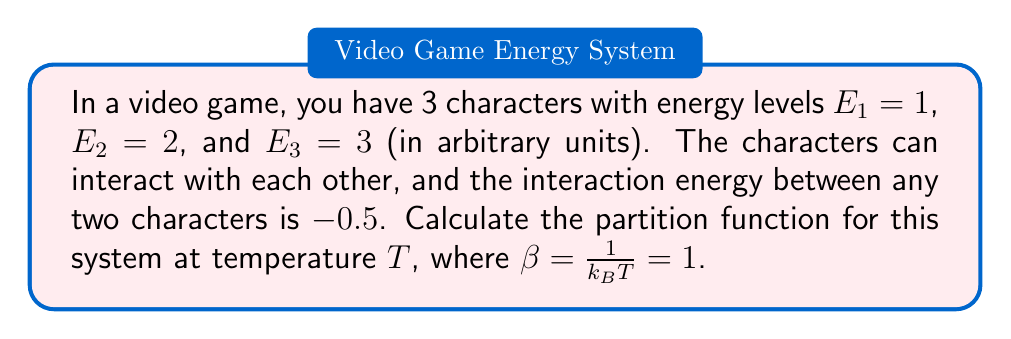Teach me how to tackle this problem. Let's approach this step-by-step:

1) The partition function Z is given by:

   $$Z = \sum_i e^{-\beta E_i}$$

   where $E_i$ is the energy of each microstate.

2) In this case, we need to consider all possible configurations of the characters:

   - All characters separate: $(1, 1, 1)$
   - Two characters interacting: $(2, 1)$, $(2, 1)$, $(2, 1)$
   - All characters interacting: $(3)$

3) Let's calculate the energy and Boltzmann factor for each configuration:

   - All separate: $E = 1 + 2 + 3 = 6$
     $$e^{-\beta E} = e^{-6} \approx 0.0025$$

   - Two interacting (3 possibilities):
     $E = (1 + 2 - 0.5) + 3 = 5.5$
     $$3 \cdot e^{-\beta E} = 3 \cdot e^{-5.5} \approx 0.0123$$

   - All interacting:
     $E = 1 + 2 + 3 - 0.5 - 0.5 - 0.5 = 4.5$
     $$e^{-\beta E} = e^{-4.5} \approx 0.0111$$

4) The partition function is the sum of all these Boltzmann factors:

   $$Z = 0.0025 + 0.0123 + 0.0111 = 0.0259$$
Answer: $Z \approx 0.0259$ 